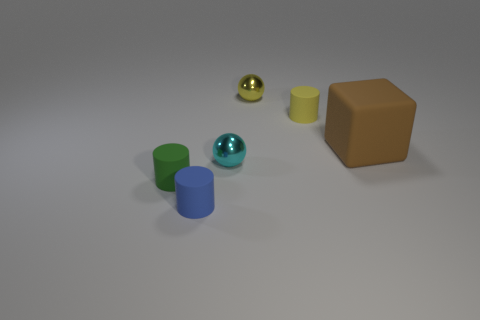How does the lighting in this image affect the appearance of the objects? The lighting in the image is soft and diffused, casting gentle shadows and creating subtle highlights. This creates a calm atmosphere and allows the true colors and textures of each object to be clearly visible without harsh reflections or deep shadows that might obscure details. 